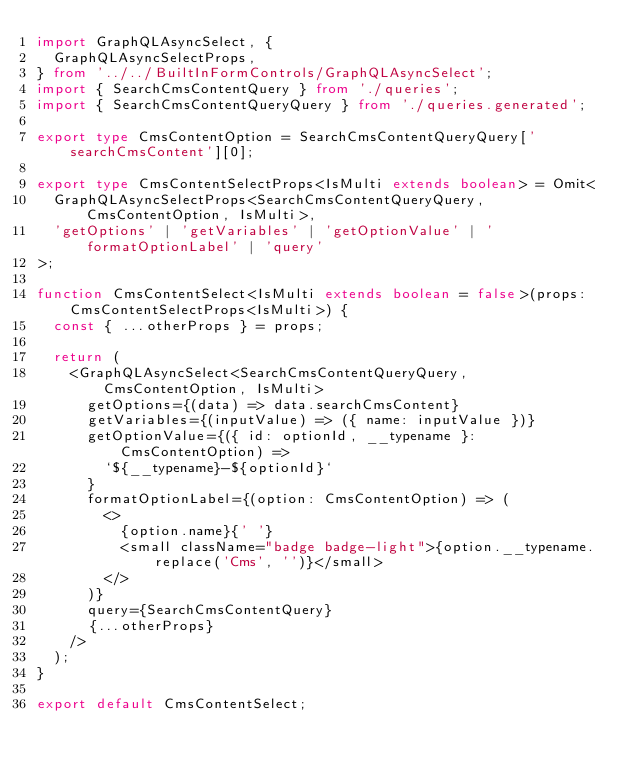Convert code to text. <code><loc_0><loc_0><loc_500><loc_500><_TypeScript_>import GraphQLAsyncSelect, {
  GraphQLAsyncSelectProps,
} from '../../BuiltInFormControls/GraphQLAsyncSelect';
import { SearchCmsContentQuery } from './queries';
import { SearchCmsContentQueryQuery } from './queries.generated';

export type CmsContentOption = SearchCmsContentQueryQuery['searchCmsContent'][0];

export type CmsContentSelectProps<IsMulti extends boolean> = Omit<
  GraphQLAsyncSelectProps<SearchCmsContentQueryQuery, CmsContentOption, IsMulti>,
  'getOptions' | 'getVariables' | 'getOptionValue' | 'formatOptionLabel' | 'query'
>;

function CmsContentSelect<IsMulti extends boolean = false>(props: CmsContentSelectProps<IsMulti>) {
  const { ...otherProps } = props;

  return (
    <GraphQLAsyncSelect<SearchCmsContentQueryQuery, CmsContentOption, IsMulti>
      getOptions={(data) => data.searchCmsContent}
      getVariables={(inputValue) => ({ name: inputValue })}
      getOptionValue={({ id: optionId, __typename }: CmsContentOption) =>
        `${__typename}-${optionId}`
      }
      formatOptionLabel={(option: CmsContentOption) => (
        <>
          {option.name}{' '}
          <small className="badge badge-light">{option.__typename.replace('Cms', '')}</small>
        </>
      )}
      query={SearchCmsContentQuery}
      {...otherProps}
    />
  );
}

export default CmsContentSelect;
</code> 